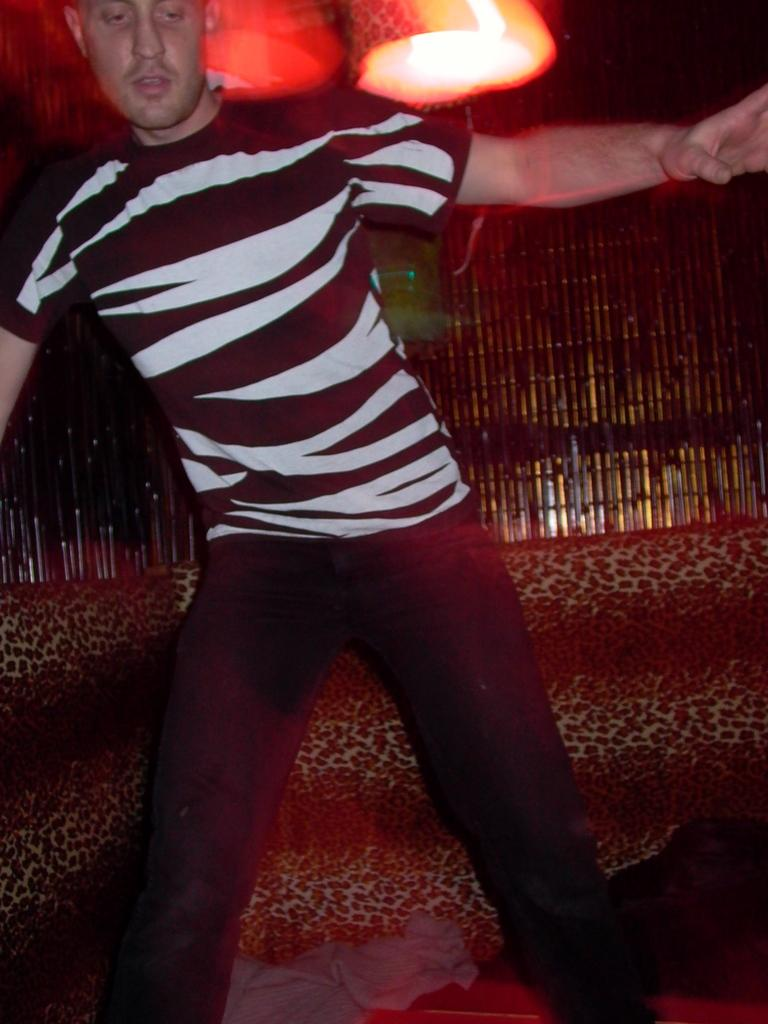What is the main subject of the image? The main subject of the image is a man standing. Can you describe the lighting in the image? There is a light at the top of the image. What type of observation can be made about the man's credit score in the image? There is no information about the man's credit score in the image. What type of wax is being used to create the man's likeness in the image? There is no indication that the man is made of wax or any other material in the image. 